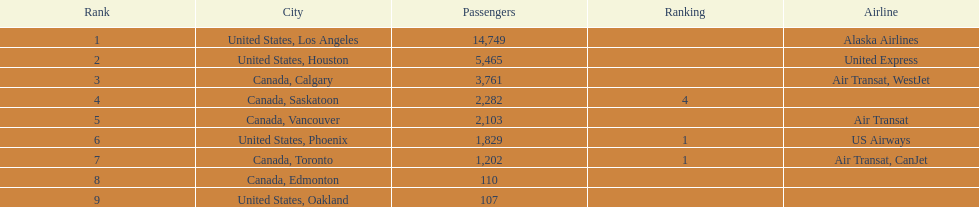What are the cities that the planes have as their destinations? United States, Los Angeles, United States, Houston, Canada, Calgary, Canada, Saskatoon, Canada, Vancouver, United States, Phoenix, Canada, Toronto, Canada, Edmonton, United States, Oakland. What is the count of people traveling to phoenix, arizona? 1,829. 